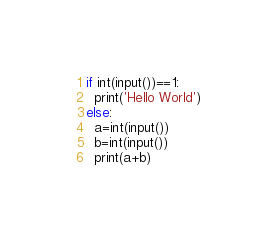<code> <loc_0><loc_0><loc_500><loc_500><_Python_>if int(input())==1:
  print('Hello World')
else:
  a=int(input())
  b=int(input())
  print(a+b)</code> 